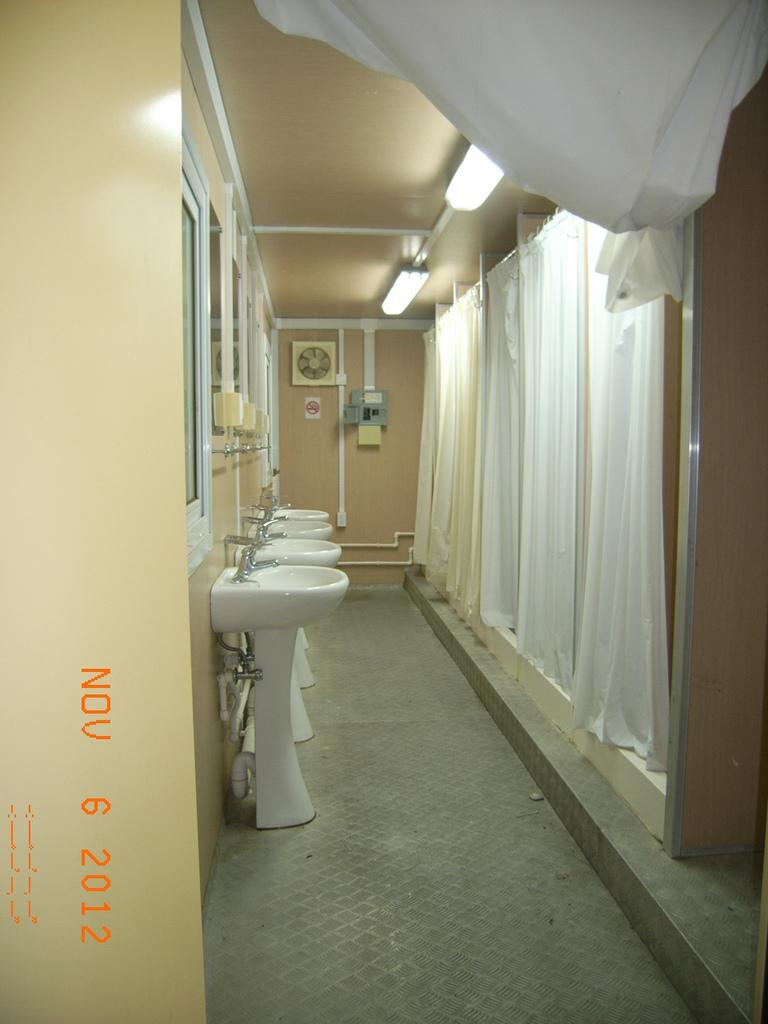What type of fixtures can be seen in the image? There are sinks in the image. What type of window treatment is present in the image? There are curtains in the image. What type of lighting is visible in the image? There are lights at the top of the image. Where are the mirrors located in the image? The mirrors are on the left side of the image, placed on the wall. What type of legal advice can be seen in the image? There is no legal advice present in the image; it features sinks, curtains, lights, and mirrors. What is the best route to take to reach the family in the image? There is no family present in the image, so it is not possible to determine the best route to reach them. 